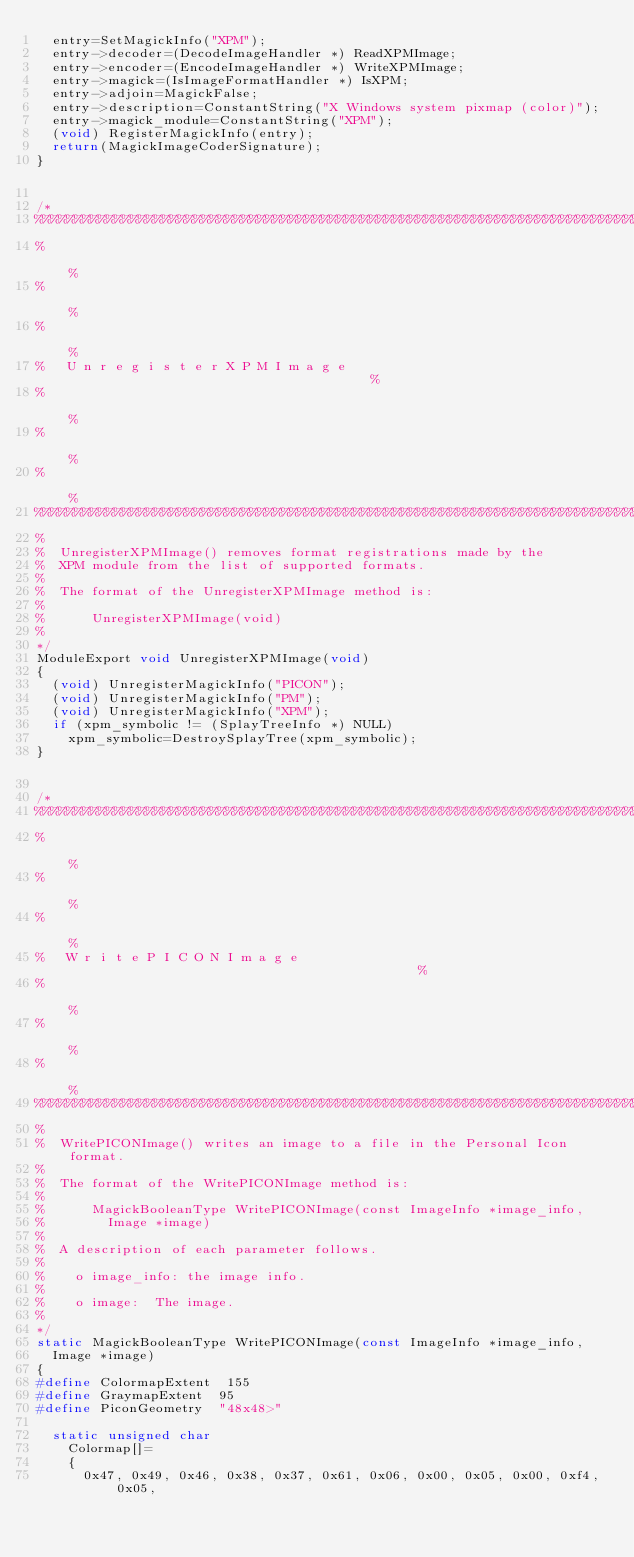<code> <loc_0><loc_0><loc_500><loc_500><_C_>  entry=SetMagickInfo("XPM");
  entry->decoder=(DecodeImageHandler *) ReadXPMImage;
  entry->encoder=(EncodeImageHandler *) WriteXPMImage;
  entry->magick=(IsImageFormatHandler *) IsXPM;
  entry->adjoin=MagickFalse;
  entry->description=ConstantString("X Windows system pixmap (color)");
  entry->magick_module=ConstantString("XPM");
  (void) RegisterMagickInfo(entry);
  return(MagickImageCoderSignature);
}

/*
%%%%%%%%%%%%%%%%%%%%%%%%%%%%%%%%%%%%%%%%%%%%%%%%%%%%%%%%%%%%%%%%%%%%%%%%%%%%%%%
%                                                                             %
%                                                                             %
%                                                                             %
%   U n r e g i s t e r X P M I m a g e                                       %
%                                                                             %
%                                                                             %
%                                                                             %
%%%%%%%%%%%%%%%%%%%%%%%%%%%%%%%%%%%%%%%%%%%%%%%%%%%%%%%%%%%%%%%%%%%%%%%%%%%%%%%
%
%  UnregisterXPMImage() removes format registrations made by the
%  XPM module from the list of supported formats.
%
%  The format of the UnregisterXPMImage method is:
%
%      UnregisterXPMImage(void)
%
*/
ModuleExport void UnregisterXPMImage(void)
{
  (void) UnregisterMagickInfo("PICON");
  (void) UnregisterMagickInfo("PM");
  (void) UnregisterMagickInfo("XPM");
  if (xpm_symbolic != (SplayTreeInfo *) NULL)
    xpm_symbolic=DestroySplayTree(xpm_symbolic);
}

/*
%%%%%%%%%%%%%%%%%%%%%%%%%%%%%%%%%%%%%%%%%%%%%%%%%%%%%%%%%%%%%%%%%%%%%%%%%%%%%%%
%                                                                             %
%                                                                             %
%                                                                             %
%   W r i t e P I C O N I m a g e                                             %
%                                                                             %
%                                                                             %
%                                                                             %
%%%%%%%%%%%%%%%%%%%%%%%%%%%%%%%%%%%%%%%%%%%%%%%%%%%%%%%%%%%%%%%%%%%%%%%%%%%%%%%
%
%  WritePICONImage() writes an image to a file in the Personal Icon format.
%
%  The format of the WritePICONImage method is:
%
%      MagickBooleanType WritePICONImage(const ImageInfo *image_info,
%        Image *image)
%
%  A description of each parameter follows.
%
%    o image_info: the image info.
%
%    o image:  The image.
%
*/
static MagickBooleanType WritePICONImage(const ImageInfo *image_info,
  Image *image)
{
#define ColormapExtent  155
#define GraymapExtent  95
#define PiconGeometry  "48x48>"

  static unsigned char
    Colormap[]=
    {
      0x47, 0x49, 0x46, 0x38, 0x37, 0x61, 0x06, 0x00, 0x05, 0x00, 0xf4, 0x05,</code> 